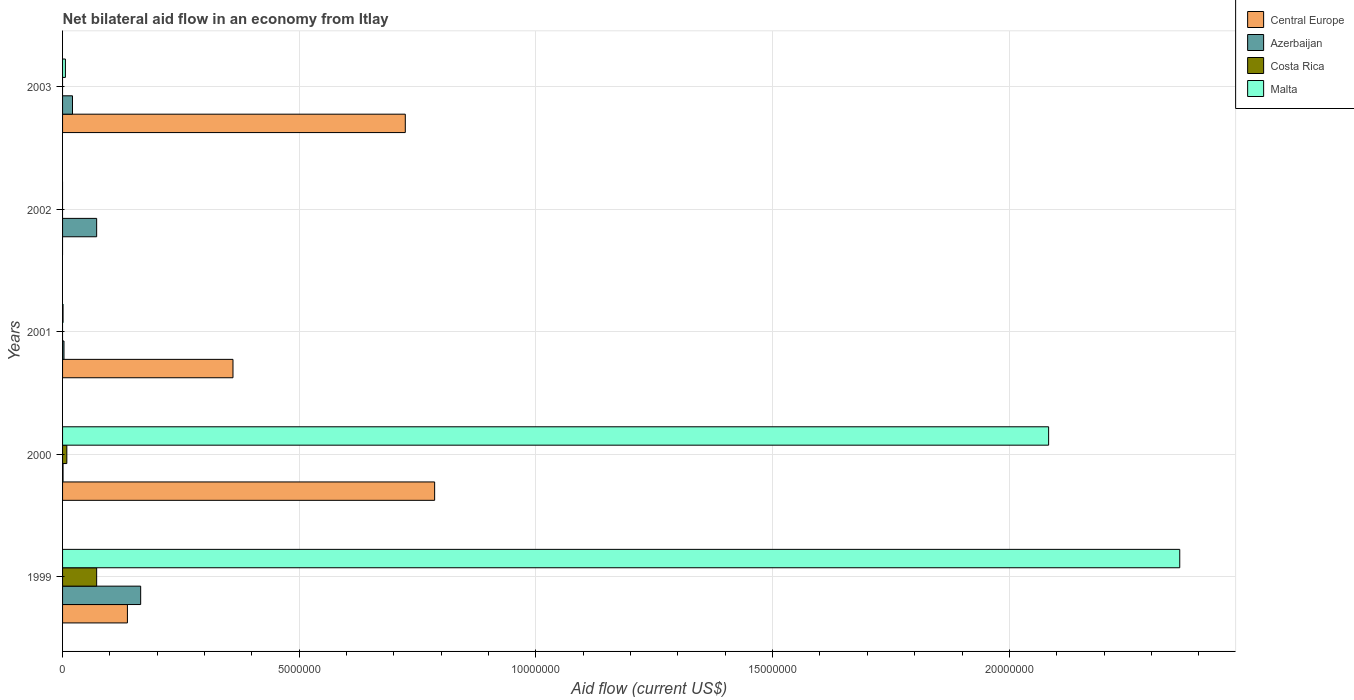How many different coloured bars are there?
Offer a very short reply. 4. Are the number of bars per tick equal to the number of legend labels?
Your response must be concise. No. Are the number of bars on each tick of the Y-axis equal?
Your answer should be very brief. No. How many bars are there on the 3rd tick from the bottom?
Give a very brief answer. 3. What is the net bilateral aid flow in Malta in 1999?
Offer a very short reply. 2.36e+07. Across all years, what is the maximum net bilateral aid flow in Costa Rica?
Provide a succinct answer. 7.20e+05. What is the total net bilateral aid flow in Costa Rica in the graph?
Offer a terse response. 8.10e+05. What is the difference between the net bilateral aid flow in Malta in 1999 and that in 2003?
Keep it short and to the point. 2.35e+07. What is the difference between the net bilateral aid flow in Costa Rica in 2000 and the net bilateral aid flow in Azerbaijan in 1999?
Your answer should be compact. -1.56e+06. What is the average net bilateral aid flow in Malta per year?
Offer a terse response. 8.90e+06. In the year 2001, what is the difference between the net bilateral aid flow in Malta and net bilateral aid flow in Azerbaijan?
Your answer should be compact. -2.00e+04. What is the ratio of the net bilateral aid flow in Central Europe in 1999 to that in 2003?
Ensure brevity in your answer.  0.19. What is the difference between the highest and the second highest net bilateral aid flow in Azerbaijan?
Provide a succinct answer. 9.30e+05. What is the difference between the highest and the lowest net bilateral aid flow in Central Europe?
Keep it short and to the point. 7.86e+06. In how many years, is the net bilateral aid flow in Malta greater than the average net bilateral aid flow in Malta taken over all years?
Your response must be concise. 2. Is the sum of the net bilateral aid flow in Malta in 1999 and 2003 greater than the maximum net bilateral aid flow in Azerbaijan across all years?
Your answer should be compact. Yes. How many bars are there?
Offer a terse response. 15. How many years are there in the graph?
Provide a succinct answer. 5. What is the difference between two consecutive major ticks on the X-axis?
Your answer should be compact. 5.00e+06. Are the values on the major ticks of X-axis written in scientific E-notation?
Ensure brevity in your answer.  No. Does the graph contain any zero values?
Ensure brevity in your answer.  Yes. Does the graph contain grids?
Offer a very short reply. Yes. Where does the legend appear in the graph?
Give a very brief answer. Top right. How many legend labels are there?
Offer a very short reply. 4. What is the title of the graph?
Keep it short and to the point. Net bilateral aid flow in an economy from Itlay. What is the label or title of the X-axis?
Your answer should be very brief. Aid flow (current US$). What is the label or title of the Y-axis?
Offer a terse response. Years. What is the Aid flow (current US$) of Central Europe in 1999?
Keep it short and to the point. 1.37e+06. What is the Aid flow (current US$) in Azerbaijan in 1999?
Provide a short and direct response. 1.65e+06. What is the Aid flow (current US$) of Costa Rica in 1999?
Provide a short and direct response. 7.20e+05. What is the Aid flow (current US$) of Malta in 1999?
Keep it short and to the point. 2.36e+07. What is the Aid flow (current US$) in Central Europe in 2000?
Offer a terse response. 7.86e+06. What is the Aid flow (current US$) of Costa Rica in 2000?
Your response must be concise. 9.00e+04. What is the Aid flow (current US$) in Malta in 2000?
Ensure brevity in your answer.  2.08e+07. What is the Aid flow (current US$) in Central Europe in 2001?
Give a very brief answer. 3.60e+06. What is the Aid flow (current US$) in Azerbaijan in 2001?
Ensure brevity in your answer.  3.00e+04. What is the Aid flow (current US$) in Costa Rica in 2001?
Provide a succinct answer. 0. What is the Aid flow (current US$) of Azerbaijan in 2002?
Keep it short and to the point. 7.20e+05. What is the Aid flow (current US$) of Costa Rica in 2002?
Provide a succinct answer. 0. What is the Aid flow (current US$) in Malta in 2002?
Ensure brevity in your answer.  0. What is the Aid flow (current US$) of Central Europe in 2003?
Your response must be concise. 7.24e+06. What is the Aid flow (current US$) in Costa Rica in 2003?
Give a very brief answer. 0. Across all years, what is the maximum Aid flow (current US$) in Central Europe?
Provide a short and direct response. 7.86e+06. Across all years, what is the maximum Aid flow (current US$) in Azerbaijan?
Keep it short and to the point. 1.65e+06. Across all years, what is the maximum Aid flow (current US$) of Costa Rica?
Offer a terse response. 7.20e+05. Across all years, what is the maximum Aid flow (current US$) of Malta?
Provide a succinct answer. 2.36e+07. Across all years, what is the minimum Aid flow (current US$) in Costa Rica?
Provide a short and direct response. 0. What is the total Aid flow (current US$) of Central Europe in the graph?
Make the answer very short. 2.01e+07. What is the total Aid flow (current US$) in Azerbaijan in the graph?
Your answer should be compact. 2.62e+06. What is the total Aid flow (current US$) in Costa Rica in the graph?
Ensure brevity in your answer.  8.10e+05. What is the total Aid flow (current US$) in Malta in the graph?
Your answer should be very brief. 4.45e+07. What is the difference between the Aid flow (current US$) in Central Europe in 1999 and that in 2000?
Your answer should be compact. -6.49e+06. What is the difference between the Aid flow (current US$) of Azerbaijan in 1999 and that in 2000?
Your answer should be compact. 1.64e+06. What is the difference between the Aid flow (current US$) of Costa Rica in 1999 and that in 2000?
Offer a terse response. 6.30e+05. What is the difference between the Aid flow (current US$) of Malta in 1999 and that in 2000?
Give a very brief answer. 2.77e+06. What is the difference between the Aid flow (current US$) of Central Europe in 1999 and that in 2001?
Provide a succinct answer. -2.23e+06. What is the difference between the Aid flow (current US$) in Azerbaijan in 1999 and that in 2001?
Your answer should be very brief. 1.62e+06. What is the difference between the Aid flow (current US$) of Malta in 1999 and that in 2001?
Your response must be concise. 2.36e+07. What is the difference between the Aid flow (current US$) of Azerbaijan in 1999 and that in 2002?
Ensure brevity in your answer.  9.30e+05. What is the difference between the Aid flow (current US$) in Central Europe in 1999 and that in 2003?
Keep it short and to the point. -5.87e+06. What is the difference between the Aid flow (current US$) in Azerbaijan in 1999 and that in 2003?
Make the answer very short. 1.44e+06. What is the difference between the Aid flow (current US$) in Malta in 1999 and that in 2003?
Your answer should be compact. 2.35e+07. What is the difference between the Aid flow (current US$) in Central Europe in 2000 and that in 2001?
Make the answer very short. 4.26e+06. What is the difference between the Aid flow (current US$) in Azerbaijan in 2000 and that in 2001?
Offer a very short reply. -2.00e+04. What is the difference between the Aid flow (current US$) in Malta in 2000 and that in 2001?
Keep it short and to the point. 2.08e+07. What is the difference between the Aid flow (current US$) in Azerbaijan in 2000 and that in 2002?
Your response must be concise. -7.10e+05. What is the difference between the Aid flow (current US$) of Central Europe in 2000 and that in 2003?
Provide a short and direct response. 6.20e+05. What is the difference between the Aid flow (current US$) in Azerbaijan in 2000 and that in 2003?
Ensure brevity in your answer.  -2.00e+05. What is the difference between the Aid flow (current US$) of Malta in 2000 and that in 2003?
Make the answer very short. 2.08e+07. What is the difference between the Aid flow (current US$) in Azerbaijan in 2001 and that in 2002?
Offer a terse response. -6.90e+05. What is the difference between the Aid flow (current US$) of Central Europe in 2001 and that in 2003?
Provide a succinct answer. -3.64e+06. What is the difference between the Aid flow (current US$) in Malta in 2001 and that in 2003?
Offer a very short reply. -5.00e+04. What is the difference between the Aid flow (current US$) in Azerbaijan in 2002 and that in 2003?
Give a very brief answer. 5.10e+05. What is the difference between the Aid flow (current US$) of Central Europe in 1999 and the Aid flow (current US$) of Azerbaijan in 2000?
Ensure brevity in your answer.  1.36e+06. What is the difference between the Aid flow (current US$) of Central Europe in 1999 and the Aid flow (current US$) of Costa Rica in 2000?
Provide a short and direct response. 1.28e+06. What is the difference between the Aid flow (current US$) of Central Europe in 1999 and the Aid flow (current US$) of Malta in 2000?
Provide a succinct answer. -1.95e+07. What is the difference between the Aid flow (current US$) of Azerbaijan in 1999 and the Aid flow (current US$) of Costa Rica in 2000?
Offer a terse response. 1.56e+06. What is the difference between the Aid flow (current US$) in Azerbaijan in 1999 and the Aid flow (current US$) in Malta in 2000?
Provide a succinct answer. -1.92e+07. What is the difference between the Aid flow (current US$) in Costa Rica in 1999 and the Aid flow (current US$) in Malta in 2000?
Your answer should be very brief. -2.01e+07. What is the difference between the Aid flow (current US$) of Central Europe in 1999 and the Aid flow (current US$) of Azerbaijan in 2001?
Offer a terse response. 1.34e+06. What is the difference between the Aid flow (current US$) in Central Europe in 1999 and the Aid flow (current US$) in Malta in 2001?
Make the answer very short. 1.36e+06. What is the difference between the Aid flow (current US$) of Azerbaijan in 1999 and the Aid flow (current US$) of Malta in 2001?
Keep it short and to the point. 1.64e+06. What is the difference between the Aid flow (current US$) of Costa Rica in 1999 and the Aid flow (current US$) of Malta in 2001?
Your response must be concise. 7.10e+05. What is the difference between the Aid flow (current US$) in Central Europe in 1999 and the Aid flow (current US$) in Azerbaijan in 2002?
Provide a succinct answer. 6.50e+05. What is the difference between the Aid flow (current US$) of Central Europe in 1999 and the Aid flow (current US$) of Azerbaijan in 2003?
Provide a short and direct response. 1.16e+06. What is the difference between the Aid flow (current US$) of Central Europe in 1999 and the Aid flow (current US$) of Malta in 2003?
Offer a terse response. 1.31e+06. What is the difference between the Aid flow (current US$) in Azerbaijan in 1999 and the Aid flow (current US$) in Malta in 2003?
Offer a very short reply. 1.59e+06. What is the difference between the Aid flow (current US$) in Central Europe in 2000 and the Aid flow (current US$) in Azerbaijan in 2001?
Ensure brevity in your answer.  7.83e+06. What is the difference between the Aid flow (current US$) of Central Europe in 2000 and the Aid flow (current US$) of Malta in 2001?
Provide a succinct answer. 7.85e+06. What is the difference between the Aid flow (current US$) in Costa Rica in 2000 and the Aid flow (current US$) in Malta in 2001?
Your response must be concise. 8.00e+04. What is the difference between the Aid flow (current US$) of Central Europe in 2000 and the Aid flow (current US$) of Azerbaijan in 2002?
Your answer should be compact. 7.14e+06. What is the difference between the Aid flow (current US$) in Central Europe in 2000 and the Aid flow (current US$) in Azerbaijan in 2003?
Keep it short and to the point. 7.65e+06. What is the difference between the Aid flow (current US$) in Central Europe in 2000 and the Aid flow (current US$) in Malta in 2003?
Your response must be concise. 7.80e+06. What is the difference between the Aid flow (current US$) in Azerbaijan in 2000 and the Aid flow (current US$) in Malta in 2003?
Provide a short and direct response. -5.00e+04. What is the difference between the Aid flow (current US$) of Central Europe in 2001 and the Aid flow (current US$) of Azerbaijan in 2002?
Ensure brevity in your answer.  2.88e+06. What is the difference between the Aid flow (current US$) in Central Europe in 2001 and the Aid flow (current US$) in Azerbaijan in 2003?
Provide a short and direct response. 3.39e+06. What is the difference between the Aid flow (current US$) in Central Europe in 2001 and the Aid flow (current US$) in Malta in 2003?
Ensure brevity in your answer.  3.54e+06. What is the average Aid flow (current US$) of Central Europe per year?
Provide a short and direct response. 4.01e+06. What is the average Aid flow (current US$) of Azerbaijan per year?
Your answer should be compact. 5.24e+05. What is the average Aid flow (current US$) in Costa Rica per year?
Your answer should be compact. 1.62e+05. What is the average Aid flow (current US$) in Malta per year?
Make the answer very short. 8.90e+06. In the year 1999, what is the difference between the Aid flow (current US$) in Central Europe and Aid flow (current US$) in Azerbaijan?
Ensure brevity in your answer.  -2.80e+05. In the year 1999, what is the difference between the Aid flow (current US$) of Central Europe and Aid flow (current US$) of Costa Rica?
Provide a short and direct response. 6.50e+05. In the year 1999, what is the difference between the Aid flow (current US$) in Central Europe and Aid flow (current US$) in Malta?
Provide a succinct answer. -2.22e+07. In the year 1999, what is the difference between the Aid flow (current US$) in Azerbaijan and Aid flow (current US$) in Costa Rica?
Provide a succinct answer. 9.30e+05. In the year 1999, what is the difference between the Aid flow (current US$) of Azerbaijan and Aid flow (current US$) of Malta?
Offer a very short reply. -2.20e+07. In the year 1999, what is the difference between the Aid flow (current US$) in Costa Rica and Aid flow (current US$) in Malta?
Give a very brief answer. -2.29e+07. In the year 2000, what is the difference between the Aid flow (current US$) of Central Europe and Aid flow (current US$) of Azerbaijan?
Your answer should be very brief. 7.85e+06. In the year 2000, what is the difference between the Aid flow (current US$) of Central Europe and Aid flow (current US$) of Costa Rica?
Your answer should be compact. 7.77e+06. In the year 2000, what is the difference between the Aid flow (current US$) of Central Europe and Aid flow (current US$) of Malta?
Offer a terse response. -1.30e+07. In the year 2000, what is the difference between the Aid flow (current US$) in Azerbaijan and Aid flow (current US$) in Costa Rica?
Offer a very short reply. -8.00e+04. In the year 2000, what is the difference between the Aid flow (current US$) of Azerbaijan and Aid flow (current US$) of Malta?
Give a very brief answer. -2.08e+07. In the year 2000, what is the difference between the Aid flow (current US$) of Costa Rica and Aid flow (current US$) of Malta?
Make the answer very short. -2.07e+07. In the year 2001, what is the difference between the Aid flow (current US$) of Central Europe and Aid flow (current US$) of Azerbaijan?
Ensure brevity in your answer.  3.57e+06. In the year 2001, what is the difference between the Aid flow (current US$) in Central Europe and Aid flow (current US$) in Malta?
Your response must be concise. 3.59e+06. In the year 2003, what is the difference between the Aid flow (current US$) of Central Europe and Aid flow (current US$) of Azerbaijan?
Your answer should be very brief. 7.03e+06. In the year 2003, what is the difference between the Aid flow (current US$) in Central Europe and Aid flow (current US$) in Malta?
Your answer should be very brief. 7.18e+06. In the year 2003, what is the difference between the Aid flow (current US$) in Azerbaijan and Aid flow (current US$) in Malta?
Keep it short and to the point. 1.50e+05. What is the ratio of the Aid flow (current US$) in Central Europe in 1999 to that in 2000?
Provide a succinct answer. 0.17. What is the ratio of the Aid flow (current US$) of Azerbaijan in 1999 to that in 2000?
Offer a terse response. 165. What is the ratio of the Aid flow (current US$) of Malta in 1999 to that in 2000?
Offer a very short reply. 1.13. What is the ratio of the Aid flow (current US$) of Central Europe in 1999 to that in 2001?
Give a very brief answer. 0.38. What is the ratio of the Aid flow (current US$) in Malta in 1999 to that in 2001?
Offer a terse response. 2360. What is the ratio of the Aid flow (current US$) of Azerbaijan in 1999 to that in 2002?
Provide a short and direct response. 2.29. What is the ratio of the Aid flow (current US$) of Central Europe in 1999 to that in 2003?
Provide a short and direct response. 0.19. What is the ratio of the Aid flow (current US$) in Azerbaijan in 1999 to that in 2003?
Offer a very short reply. 7.86. What is the ratio of the Aid flow (current US$) in Malta in 1999 to that in 2003?
Make the answer very short. 393.33. What is the ratio of the Aid flow (current US$) of Central Europe in 2000 to that in 2001?
Give a very brief answer. 2.18. What is the ratio of the Aid flow (current US$) of Malta in 2000 to that in 2001?
Ensure brevity in your answer.  2083. What is the ratio of the Aid flow (current US$) of Azerbaijan in 2000 to that in 2002?
Provide a succinct answer. 0.01. What is the ratio of the Aid flow (current US$) in Central Europe in 2000 to that in 2003?
Provide a short and direct response. 1.09. What is the ratio of the Aid flow (current US$) in Azerbaijan in 2000 to that in 2003?
Your answer should be compact. 0.05. What is the ratio of the Aid flow (current US$) of Malta in 2000 to that in 2003?
Your answer should be compact. 347.17. What is the ratio of the Aid flow (current US$) in Azerbaijan in 2001 to that in 2002?
Give a very brief answer. 0.04. What is the ratio of the Aid flow (current US$) in Central Europe in 2001 to that in 2003?
Offer a terse response. 0.5. What is the ratio of the Aid flow (current US$) of Azerbaijan in 2001 to that in 2003?
Give a very brief answer. 0.14. What is the ratio of the Aid flow (current US$) in Azerbaijan in 2002 to that in 2003?
Keep it short and to the point. 3.43. What is the difference between the highest and the second highest Aid flow (current US$) in Central Europe?
Provide a short and direct response. 6.20e+05. What is the difference between the highest and the second highest Aid flow (current US$) in Azerbaijan?
Provide a succinct answer. 9.30e+05. What is the difference between the highest and the second highest Aid flow (current US$) of Malta?
Offer a terse response. 2.77e+06. What is the difference between the highest and the lowest Aid flow (current US$) in Central Europe?
Your response must be concise. 7.86e+06. What is the difference between the highest and the lowest Aid flow (current US$) of Azerbaijan?
Your answer should be very brief. 1.64e+06. What is the difference between the highest and the lowest Aid flow (current US$) in Costa Rica?
Your answer should be compact. 7.20e+05. What is the difference between the highest and the lowest Aid flow (current US$) in Malta?
Your answer should be very brief. 2.36e+07. 